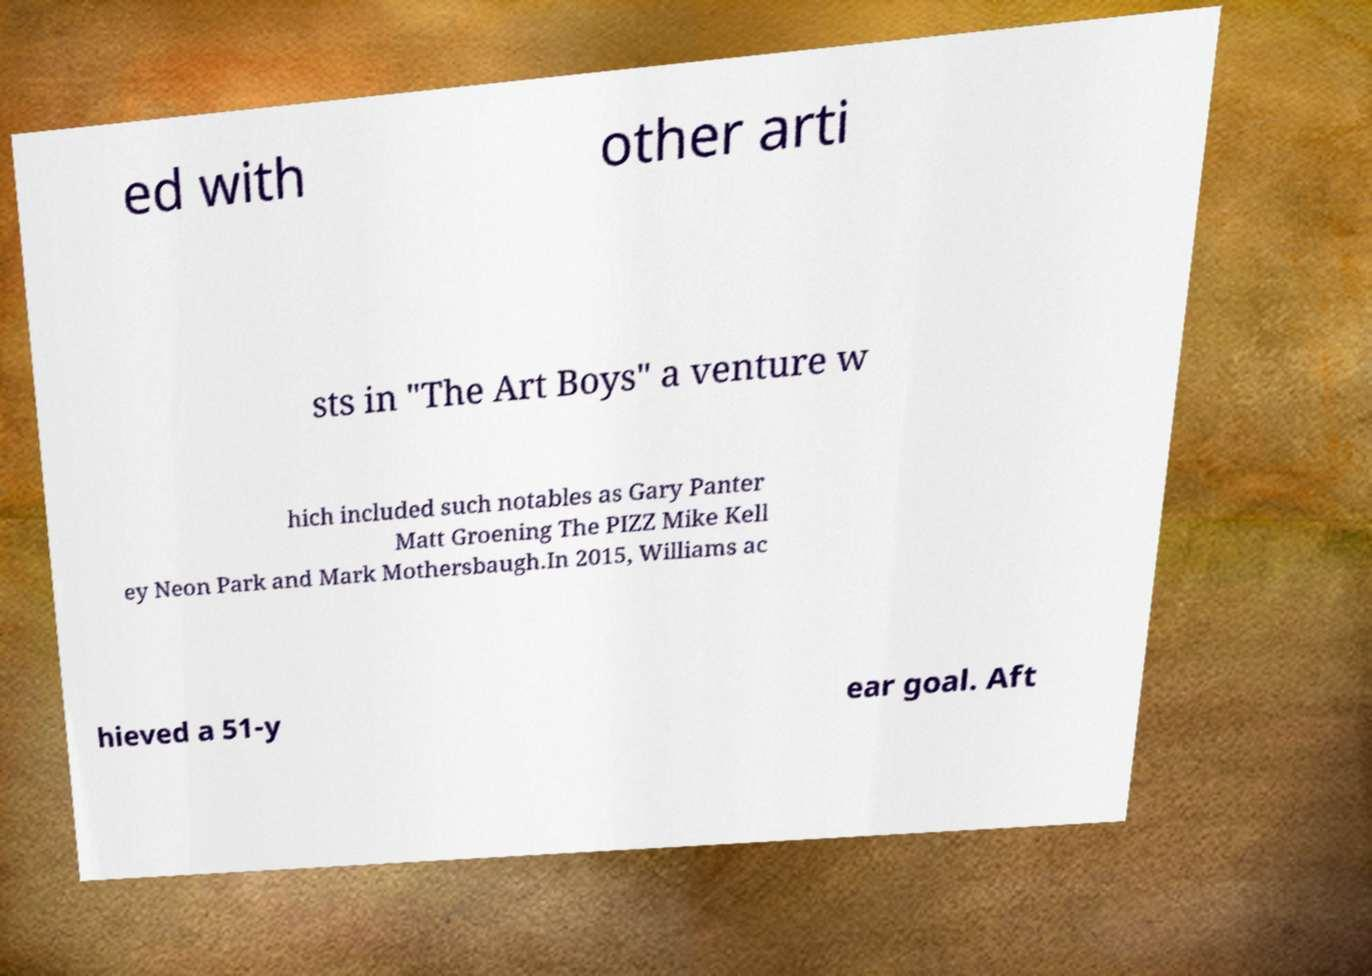There's text embedded in this image that I need extracted. Can you transcribe it verbatim? ed with other arti sts in "The Art Boys" a venture w hich included such notables as Gary Panter Matt Groening The PIZZ Mike Kell ey Neon Park and Mark Mothersbaugh.In 2015, Williams ac hieved a 51-y ear goal. Aft 